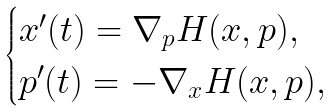Convert formula to latex. <formula><loc_0><loc_0><loc_500><loc_500>\begin{cases} x ^ { \prime } ( t ) = \nabla _ { p } H ( x , p ) , \\ p ^ { \prime } ( t ) = - \nabla _ { x } H ( x , p ) , \end{cases}</formula> 